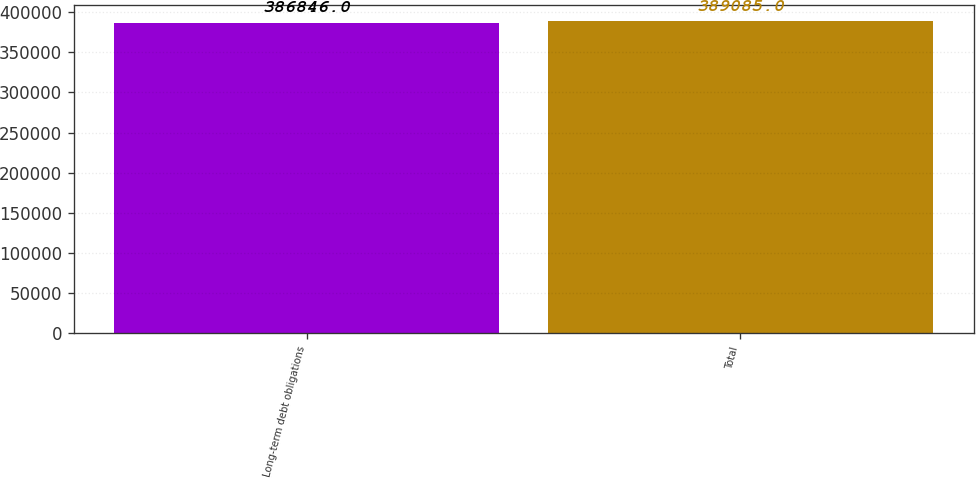<chart> <loc_0><loc_0><loc_500><loc_500><bar_chart><fcel>Long-term debt obligations<fcel>Total<nl><fcel>386846<fcel>389085<nl></chart> 